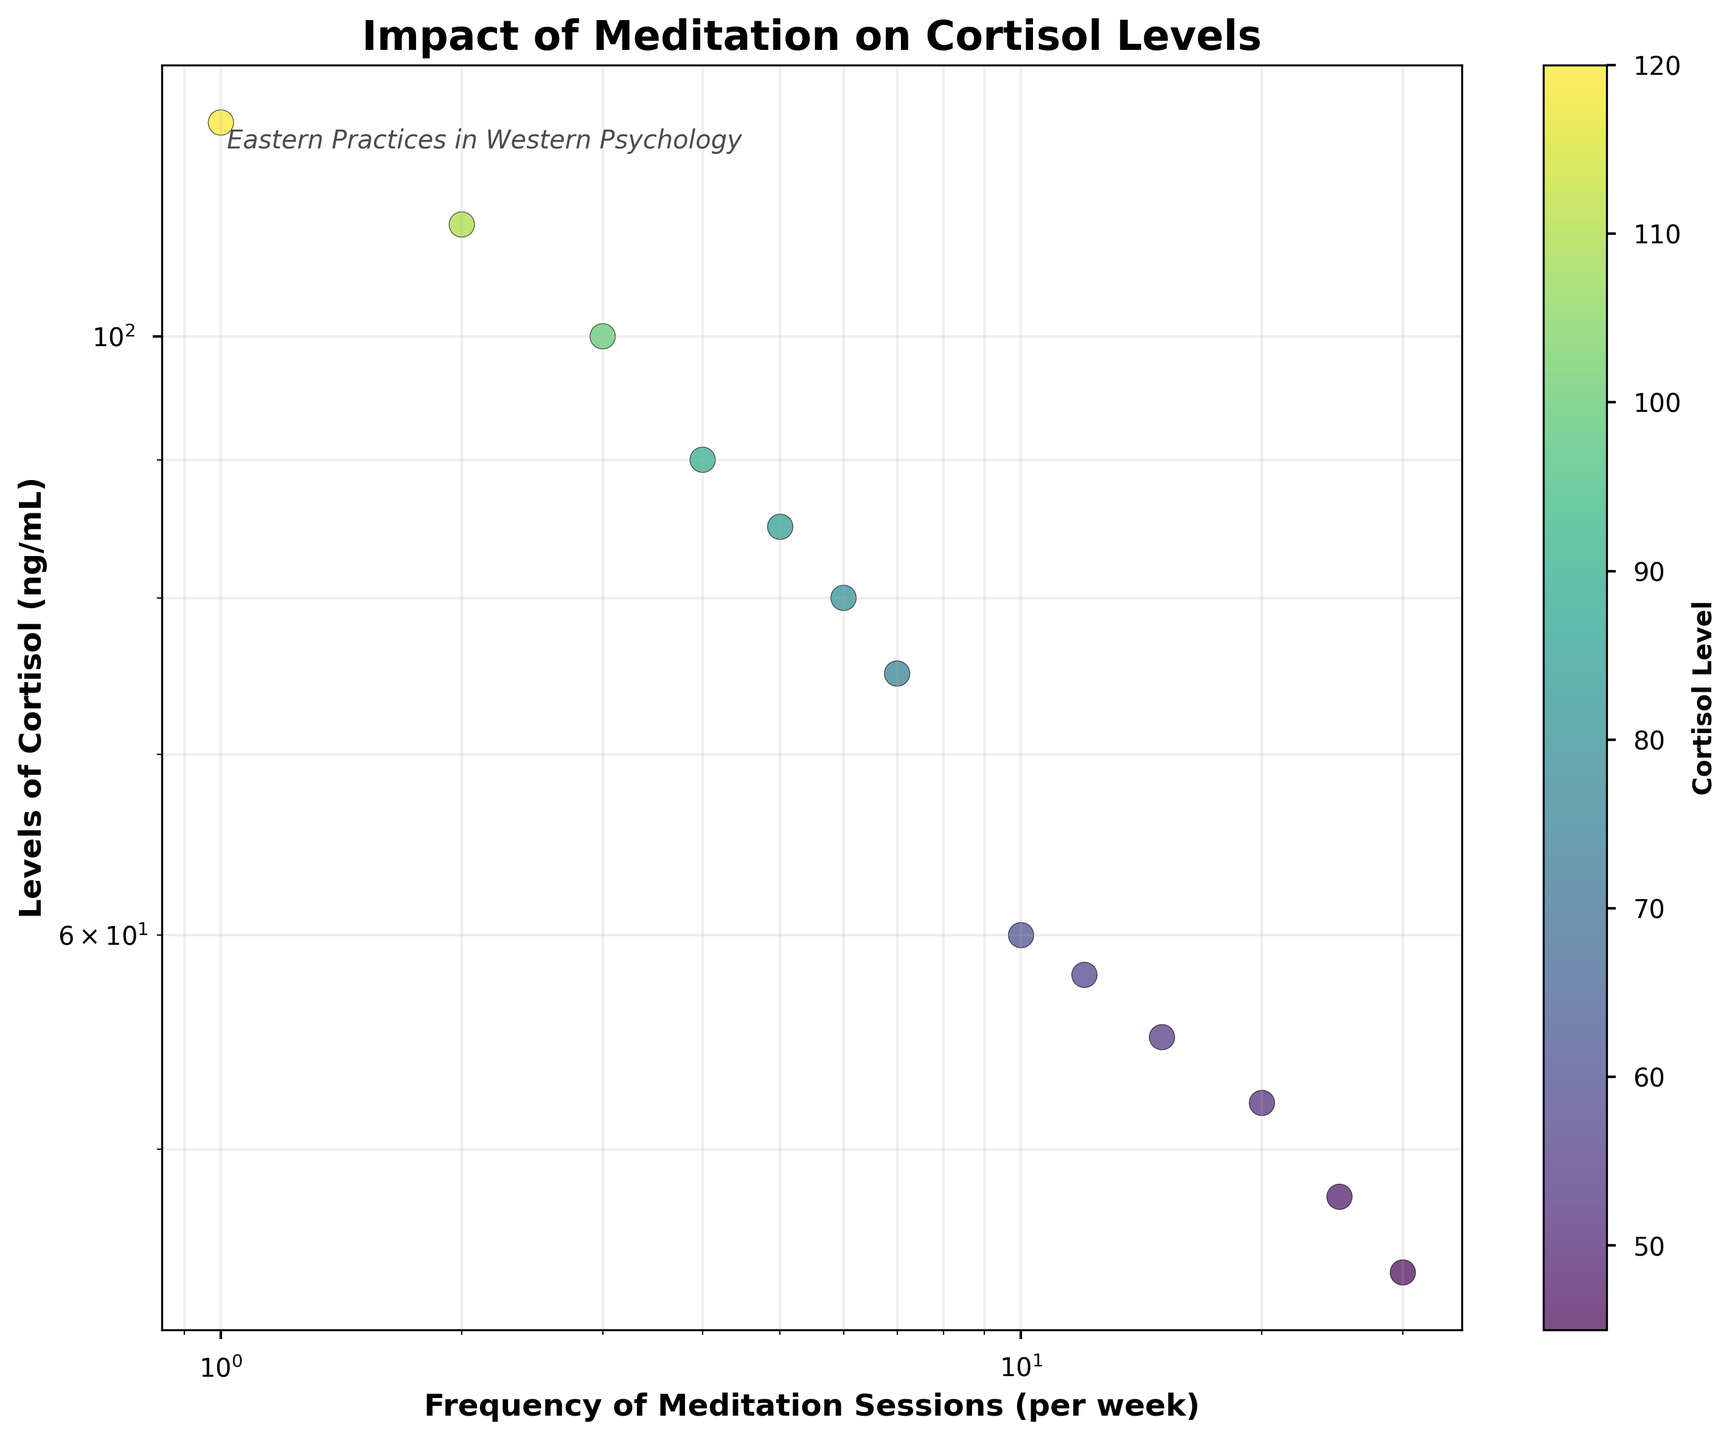What's the title of the figure? The title of the figure is typically displayed prominently at the top. In this case, it is clearly labeled at the top of the plot.
Answer: Impact of Meditation on Cortisol Levels How many data points are displayed in the scatter plot? The scatter plot contains distinct points representing the measured data. By counting the dots on the plot, we can determine the number of data points.
Answer: 13 What's the color scheme used for the data points in the scatter plot? The scatter plot uses a color scheme to represent the data points, which is determined by examining the plot's colormap. In this case, they are colored from blue to yellow to green.
Answer: Viridis Within what range do the 'Frequency of Meditation Sessions' values fall? The x-axis represents the 'Frequency of Meditation Sessions', enabling us to examine the scale to determine the range. The log scale distorts the appearance but starts from 1 and extends to 30 as the outermost points.
Answer: 1 to 30 What is the range of 'Levels of Cortisol' presented in this figure? By examining the y-axis labels, we can identify the range. The log scale for cortisol levels starts from 45 ng/mL to 120 ng/mL.
Answer: 45 to 120 ng/mL What's the average 'Levels of Cortisol' for meditation frequencies of 2, 4, and 6 sessions per week? First, identify the cortisol levels for these frequencies, which are 110, 90, and 80 respectively. Sum these values (110 + 90 + 80 = 280) and divide by 3 to find the average (280/3 ≈ 93.3).
Answer: ~93.3 ng/mL Is there a general trend observable in the relationship between 'Frequency of Meditation Sessions' and 'Levels of Cortisol'? By examining the scatter pattern and the log-log scale, we see a downward trend where increased meditation frequency corresponds to lower cortisol levels.
Answer: Yes, lower cortisol with higher frequency How does the 'Levels of Cortisol' change when meditation frequency doubles from 5 to 10 sessions per week? Examine the cortisol values at frequencies of 5 and 10 sessions per week, which are 85 and 60 respectively. Calculate the change in levels (85 - 60 = 25 ng/mL).
Answer: Decreases by 25 ng/mL Which data point has the highest 'Levels of Cortisol', and what is its corresponding 'Frequency of Meditation Sessions'? The highest cortisol level is found by looking at the topmost point on the scatter plot. The corresponding frequency for this top point is 1 session per week.
Answer: 120 ng/mL at 1 session per week What is the relationship between the datapoints with frequencies of 7 and 20 meditation sessions per week in terms of cortisol levels? Compare cortisol levels for frequencies of 7 and 20 sessions per week, which are 75 and 52 respectively. The relationship shows that at 20 sessions, the cortisol level is lower than at 7 sessions per week.
Answer: 52 ng/mL is lower than 75 ng/mL 